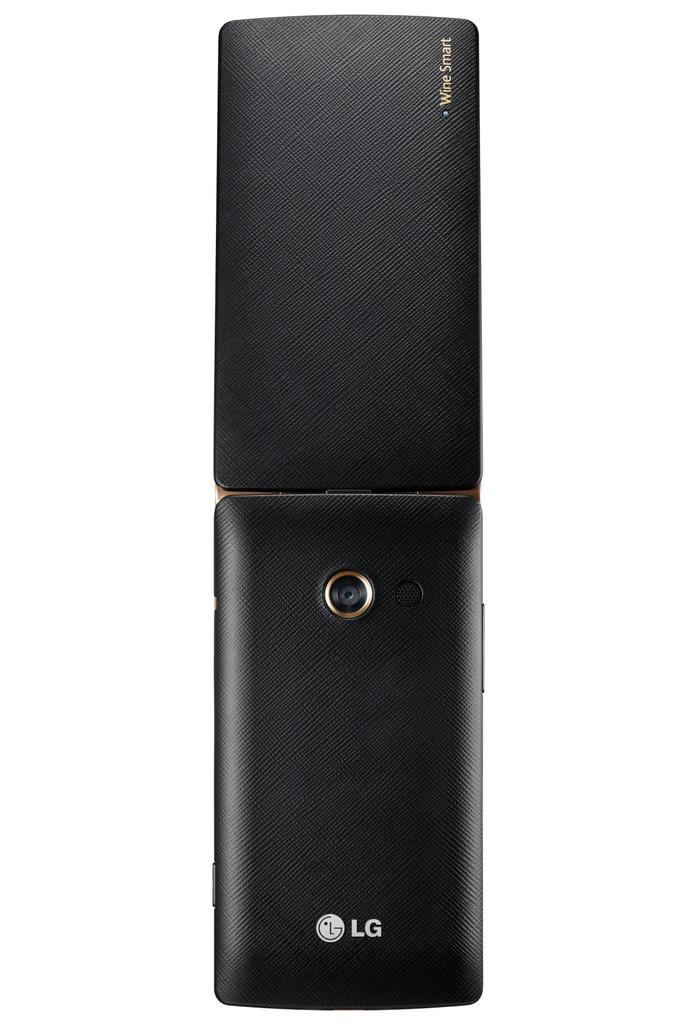<image>
Give a short and clear explanation of the subsequent image. A black LG phone shown from the back side next to something else with the words Wine Smart on it. 